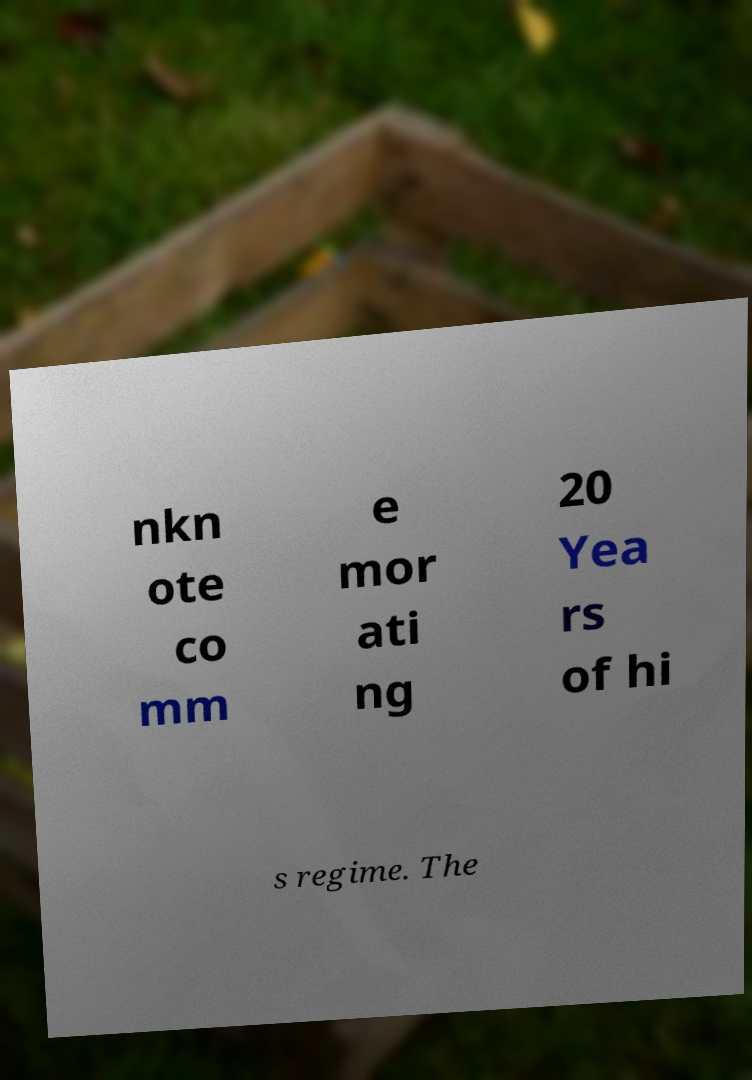Please identify and transcribe the text found in this image. nkn ote co mm e mor ati ng 20 Yea rs of hi s regime. The 